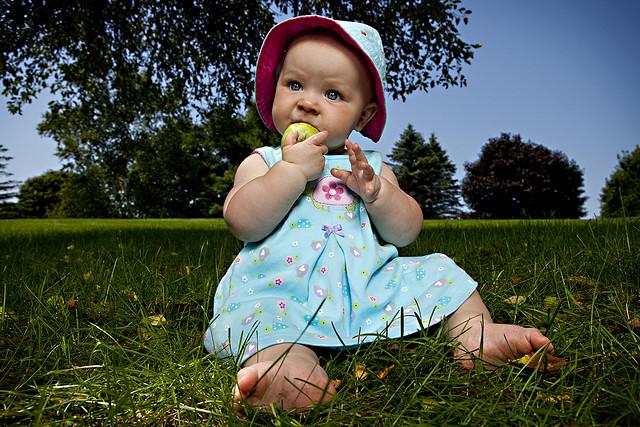What kind of shorts is the child wearing?
Be succinct. None. Is the baby sitting on the grass?
Give a very brief answer. Yes. What is the baby eating?
Write a very short answer. Apple. Is this a healthy habit?
Be succinct. Yes. Is the little girl wearing shoes?
Be succinct. No. Is this child overweight?
Be succinct. No. What food is the girl eating?
Be succinct. Apple. What time of day is it?
Write a very short answer. Afternoon. What is the baby holding?
Keep it brief. Apple. Is she on the sidewalk?
Give a very brief answer. No. What decorates the front of her jumper?
Answer briefly. Flowers. 